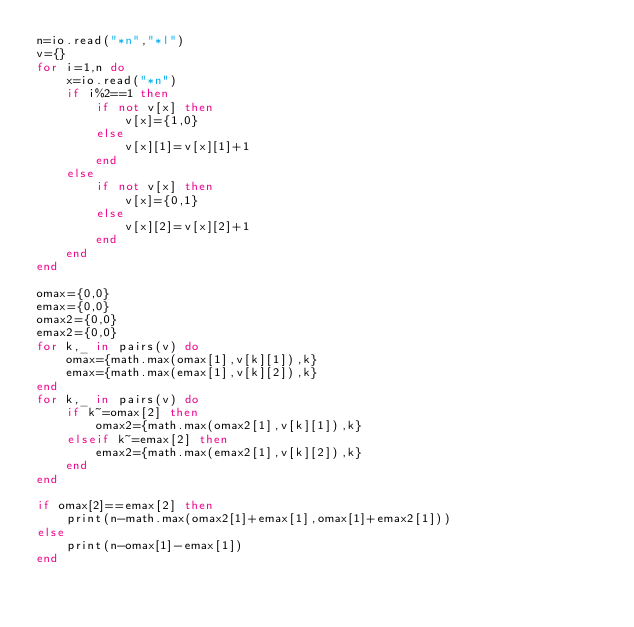<code> <loc_0><loc_0><loc_500><loc_500><_Lua_>n=io.read("*n","*l")
v={}
for i=1,n do
    x=io.read("*n")
    if i%2==1 then
        if not v[x] then
            v[x]={1,0}
        else
            v[x][1]=v[x][1]+1
        end
    else
        if not v[x] then
            v[x]={0,1}
        else
            v[x][2]=v[x][2]+1
        end
    end
end

omax={0,0}
emax={0,0}
omax2={0,0}
emax2={0,0}
for k,_ in pairs(v) do
    omax={math.max(omax[1],v[k][1]),k}
    emax={math.max(emax[1],v[k][2]),k}
end
for k,_ in pairs(v) do
    if k~=omax[2] then
        omax2={math.max(omax2[1],v[k][1]),k}
    elseif k~=emax[2] then
        emax2={math.max(emax2[1],v[k][2]),k}
    end
end

if omax[2]==emax[2] then
    print(n-math.max(omax2[1]+emax[1],omax[1]+emax2[1]))
else
    print(n-omax[1]-emax[1])
end</code> 